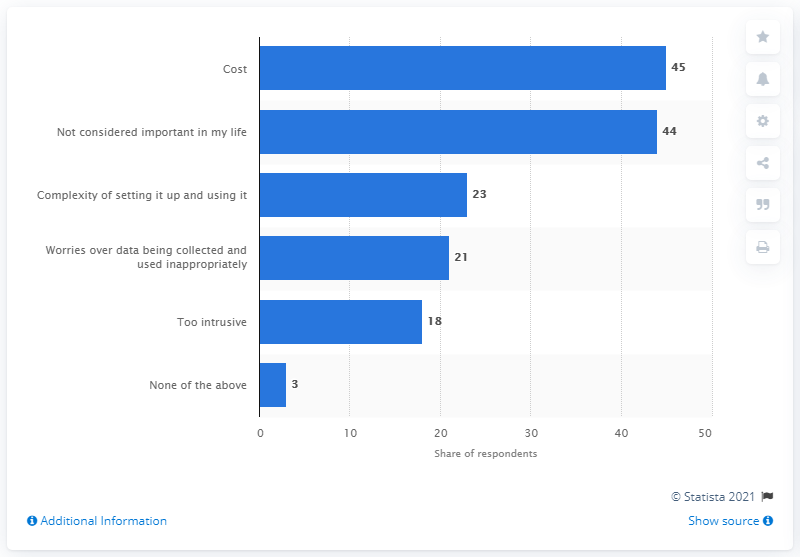Highlight a few significant elements in this photo. According to the responses, 45% of respondents cited the cost of smart devices as the reason for not having one installed in their home. 